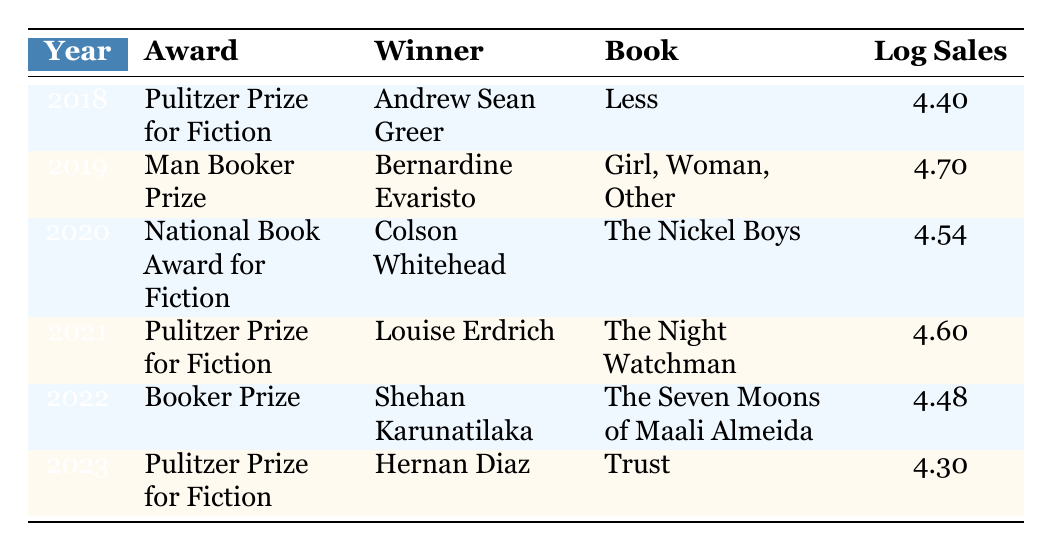What is the log sales figure for the book "Less"? The table shows the entry for the year 2018, where the book "Less" by Andrew Sean Greer won the Pulitzer Prize for Fiction. The corresponding log sales value is listed directly next to the book title, which is 4.40.
Answer: 4.40 Who won the Man Booker Prize in 2019? By looking at the row for the year 2019 in the table, we can see that Bernardine Evaristo is the winner, identified by the award listed and the corresponding winner.
Answer: Bernardine Evaristo What are the total log sales figures for the years 2018 and 2021? To find the total log sales for these years, we look at each row: for 2018 the log sales is 4.40, and for 2021 it's 4.60. We add these two numbers together: 4.40 + 4.60 = 9.00.
Answer: 9.00 Did Hernan Diaz's book have higher or lower log sales than Colson Whitehead's book? We check the log sales values: Hernan Diaz's book "Trust" has a log sales value of 4.30, while Colson Whitehead's "The Nickel Boys" has a log sales value of 4.54. Since 4.30 is less than 4.54, the answer is that Hernan Diaz's log sales are lower.
Answer: Lower What is the average log sales figure for the entries in the table? To calculate the average, we first sum all the log sales figures: 4.40 + 4.70 + 4.54 + 4.60 + 4.48 + 4.30 = 27.02. There are 6 entries, so we divide the total by 6: 27.02 / 6 = approximately 4.5033.
Answer: Approximately 4.50 Which book had the highest log sales and what was the figure? We can identify the highest log sales by examining each entry. The book "Girl, Woman, Other" by Bernardine Evaristo from 2019 has the highest log sales figure recorded at 4.70.
Answer: 4.70 Should we infer that "The Seven Moons of Maali Almeida" had better sales than "Trust"? Looking at the sales figures, "The Seven Moons of Maali Almeida" has 30,000, while "Trust" has 20,000. Since 30,000 is greater than 20,000, we confirm that it had better sales.
Answer: Yes How many awards are listed for the year 2022? According to the table, only one entry is present under the year 2022, which is for the Booker Prize won by Shehan Karunatilaka. Therefore, there is only one award listed.
Answer: One 